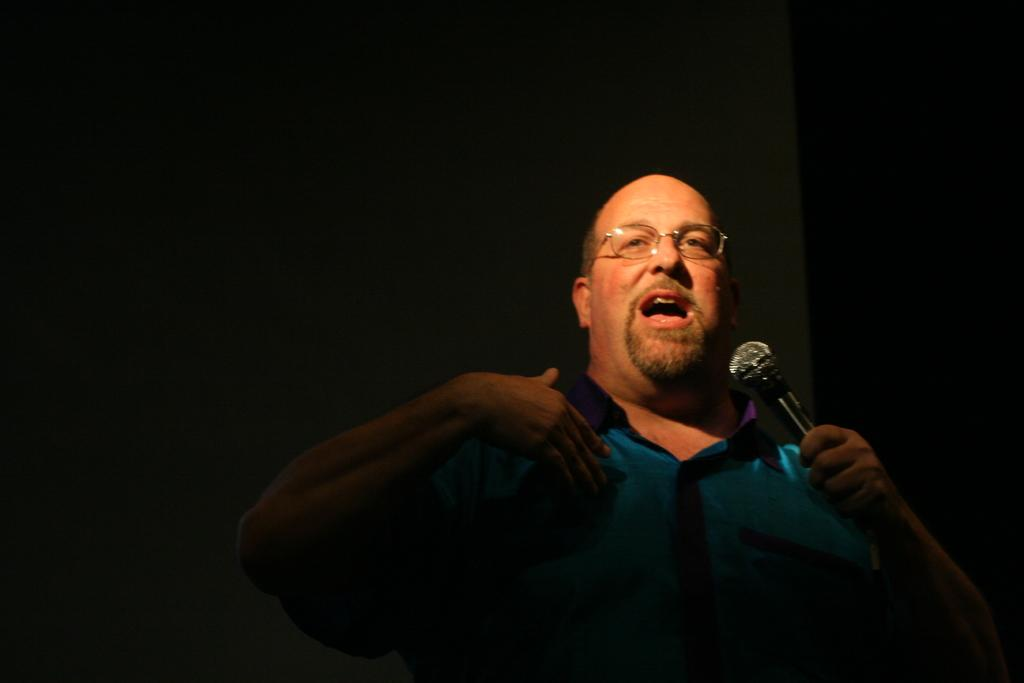Who is the main subject in the image? There is a man in the image. What is the man holding in the image? The man is holding a microphone. What is the man doing in the image? The man is talking. What can be seen in the background of the image? There is a black wall in the background of the image. How does the man measure the length of the microphone in the image? The image does not show the man measuring the length of the microphone; he is simply holding it while talking. 